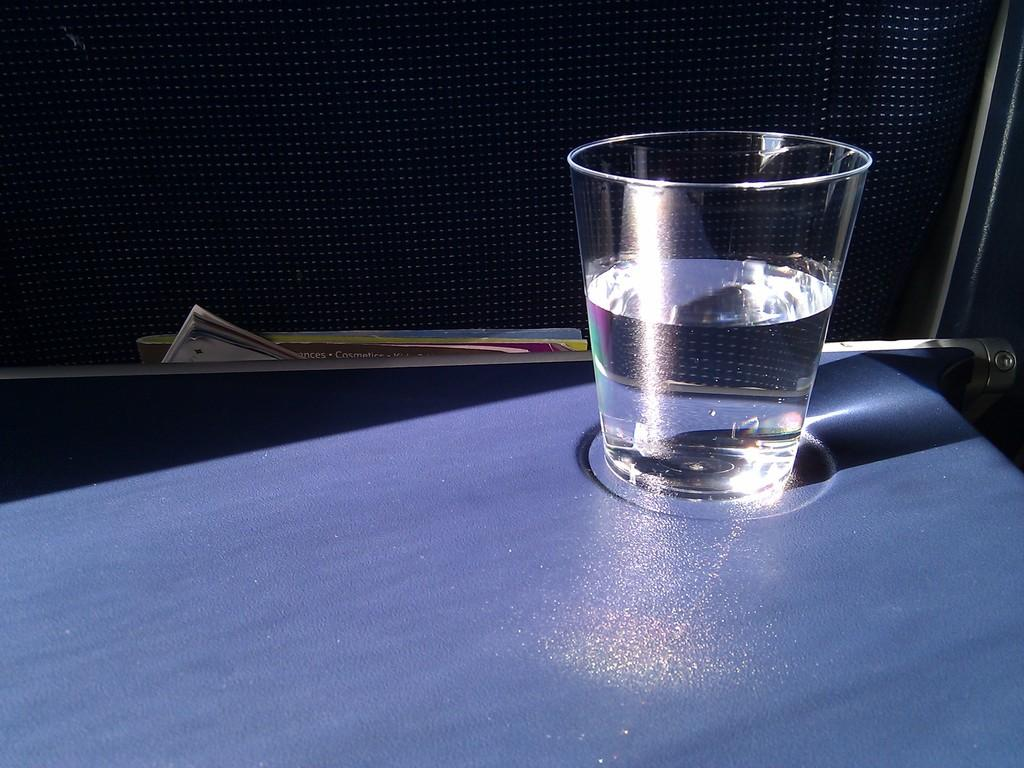What is in the glass that is visible in the image? There is a glass of water in the image. Where is the glass of water located? The glass of water is on a table in the image. What type of furniture is present in the image? There is a chair in the image. What else can be seen on the table besides the glass of water? There are books in the image. Where is the cemetery located in the image? There is no cemetery present in the image. What type of frame is around the books in the image? There is no frame around the books in the image; they are simply placed on the table. 